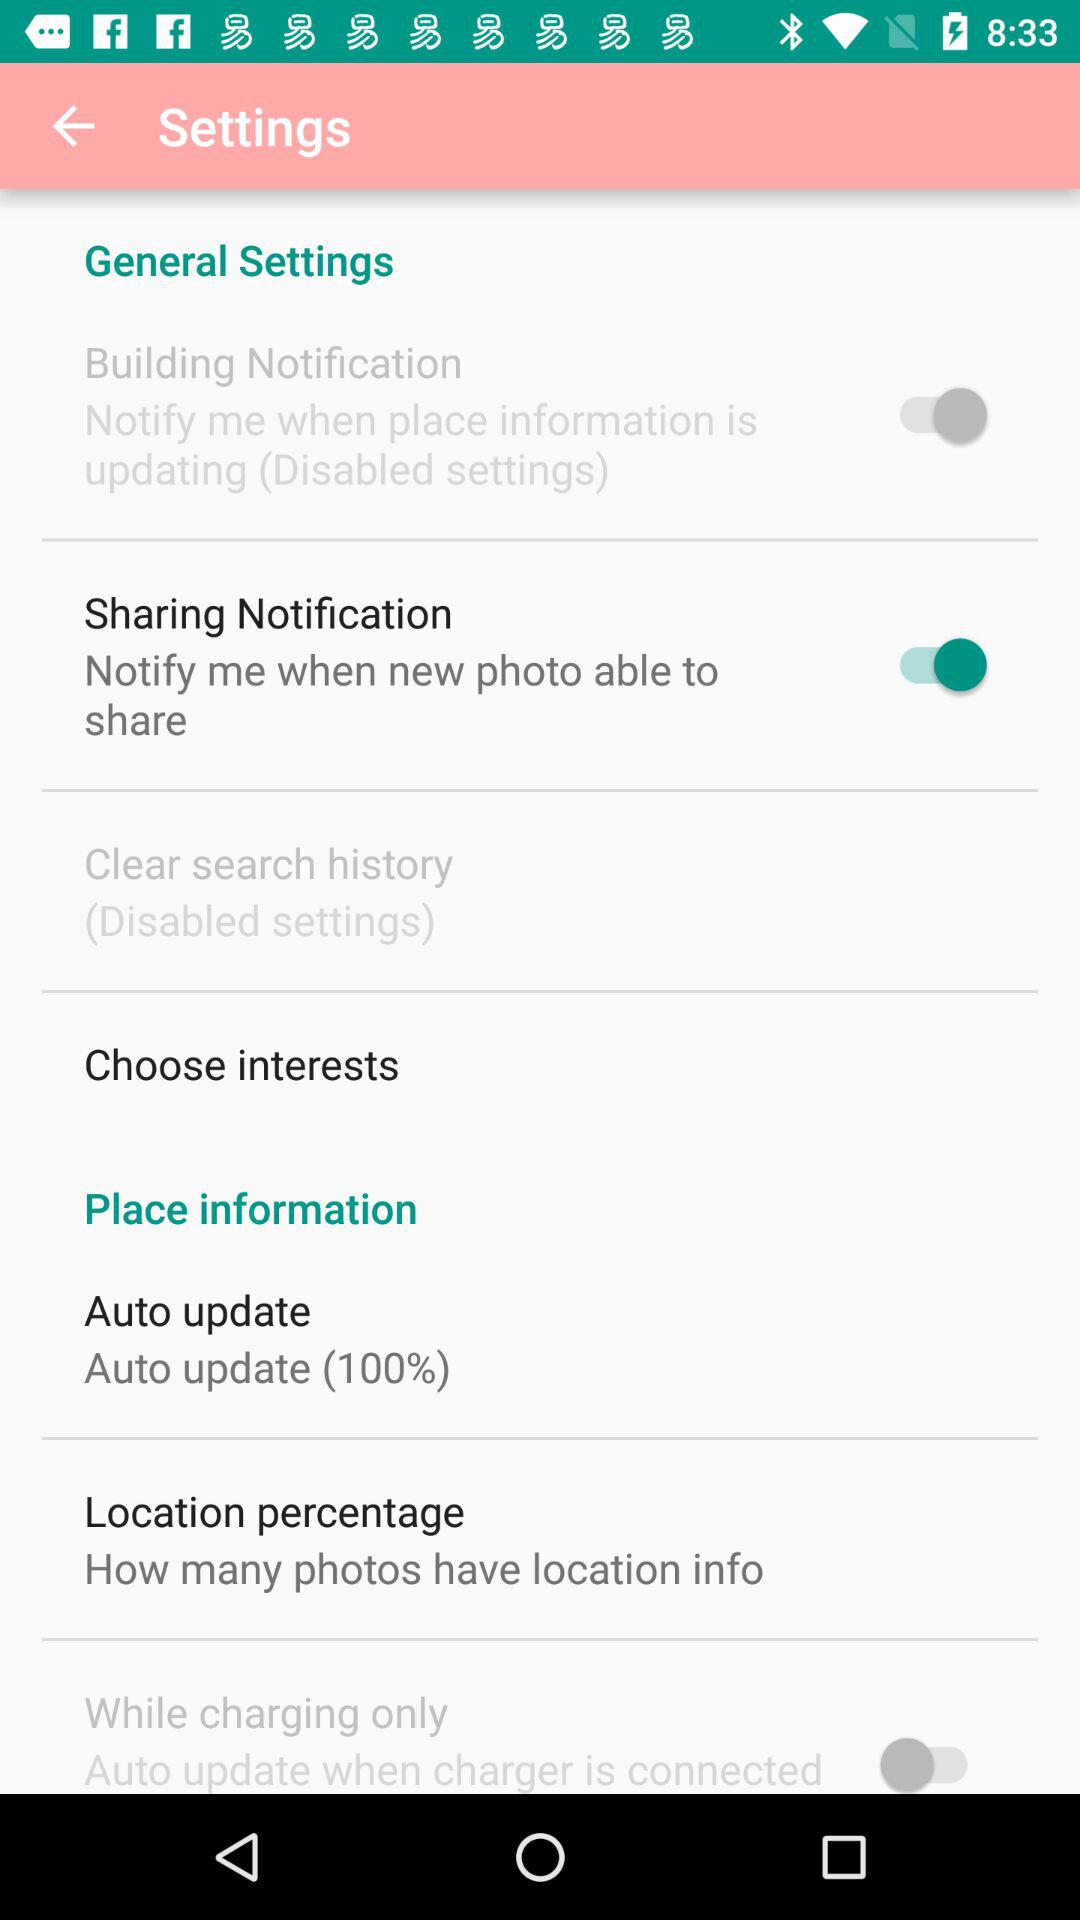What is the percentage of "Auto update"? The percentage is 100. 